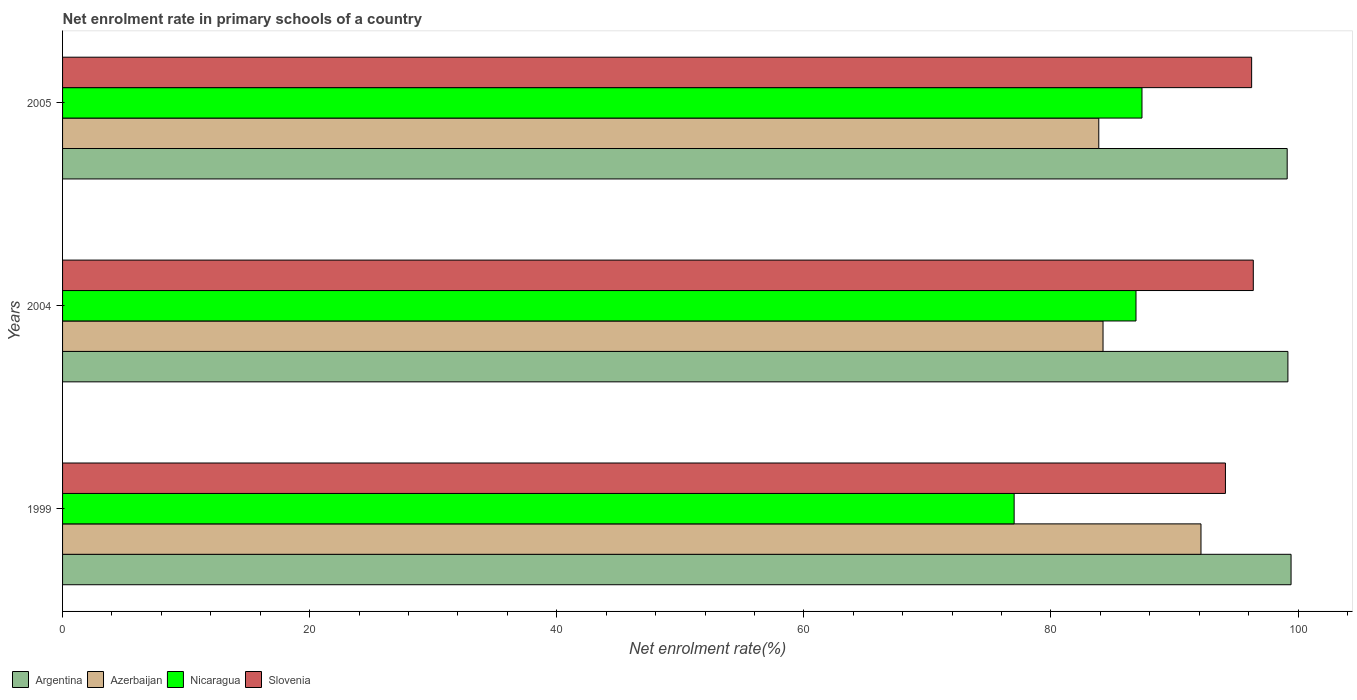Are the number of bars per tick equal to the number of legend labels?
Offer a very short reply. Yes. Are the number of bars on each tick of the Y-axis equal?
Your answer should be compact. Yes. In how many cases, is the number of bars for a given year not equal to the number of legend labels?
Give a very brief answer. 0. What is the net enrolment rate in primary schools in Slovenia in 2004?
Your answer should be very brief. 96.38. Across all years, what is the maximum net enrolment rate in primary schools in Slovenia?
Your response must be concise. 96.38. Across all years, what is the minimum net enrolment rate in primary schools in Nicaragua?
Provide a succinct answer. 77.02. In which year was the net enrolment rate in primary schools in Nicaragua maximum?
Provide a succinct answer. 2005. What is the total net enrolment rate in primary schools in Argentina in the graph?
Give a very brief answer. 297.73. What is the difference between the net enrolment rate in primary schools in Argentina in 1999 and that in 2005?
Ensure brevity in your answer.  0.31. What is the difference between the net enrolment rate in primary schools in Azerbaijan in 2005 and the net enrolment rate in primary schools in Nicaragua in 1999?
Your response must be concise. 6.85. What is the average net enrolment rate in primary schools in Argentina per year?
Give a very brief answer. 99.24. In the year 2005, what is the difference between the net enrolment rate in primary schools in Azerbaijan and net enrolment rate in primary schools in Nicaragua?
Your response must be concise. -3.5. In how many years, is the net enrolment rate in primary schools in Azerbaijan greater than 12 %?
Offer a very short reply. 3. What is the ratio of the net enrolment rate in primary schools in Azerbaijan in 2004 to that in 2005?
Give a very brief answer. 1. Is the net enrolment rate in primary schools in Argentina in 1999 less than that in 2004?
Offer a very short reply. No. Is the difference between the net enrolment rate in primary schools in Azerbaijan in 1999 and 2004 greater than the difference between the net enrolment rate in primary schools in Nicaragua in 1999 and 2004?
Your response must be concise. Yes. What is the difference between the highest and the second highest net enrolment rate in primary schools in Argentina?
Offer a terse response. 0.26. What is the difference between the highest and the lowest net enrolment rate in primary schools in Argentina?
Give a very brief answer. 0.31. In how many years, is the net enrolment rate in primary schools in Nicaragua greater than the average net enrolment rate in primary schools in Nicaragua taken over all years?
Give a very brief answer. 2. What does the 1st bar from the top in 2005 represents?
Your answer should be compact. Slovenia. What does the 4th bar from the bottom in 2004 represents?
Offer a terse response. Slovenia. Are all the bars in the graph horizontal?
Offer a terse response. Yes. How many years are there in the graph?
Give a very brief answer. 3. Are the values on the major ticks of X-axis written in scientific E-notation?
Keep it short and to the point. No. Does the graph contain any zero values?
Offer a very short reply. No. How are the legend labels stacked?
Give a very brief answer. Horizontal. What is the title of the graph?
Your answer should be compact. Net enrolment rate in primary schools of a country. Does "Cuba" appear as one of the legend labels in the graph?
Offer a very short reply. No. What is the label or title of the X-axis?
Give a very brief answer. Net enrolment rate(%). What is the label or title of the Y-axis?
Provide a succinct answer. Years. What is the Net enrolment rate(%) in Argentina in 1999?
Keep it short and to the point. 99.43. What is the Net enrolment rate(%) of Azerbaijan in 1999?
Ensure brevity in your answer.  92.14. What is the Net enrolment rate(%) of Nicaragua in 1999?
Ensure brevity in your answer.  77.02. What is the Net enrolment rate(%) of Slovenia in 1999?
Make the answer very short. 94.12. What is the Net enrolment rate(%) of Argentina in 2004?
Offer a terse response. 99.18. What is the Net enrolment rate(%) of Azerbaijan in 2004?
Keep it short and to the point. 84.21. What is the Net enrolment rate(%) in Nicaragua in 2004?
Make the answer very short. 86.88. What is the Net enrolment rate(%) of Slovenia in 2004?
Give a very brief answer. 96.38. What is the Net enrolment rate(%) of Argentina in 2005?
Offer a very short reply. 99.12. What is the Net enrolment rate(%) of Azerbaijan in 2005?
Your response must be concise. 83.87. What is the Net enrolment rate(%) of Nicaragua in 2005?
Provide a succinct answer. 87.37. What is the Net enrolment rate(%) in Slovenia in 2005?
Give a very brief answer. 96.24. Across all years, what is the maximum Net enrolment rate(%) in Argentina?
Ensure brevity in your answer.  99.43. Across all years, what is the maximum Net enrolment rate(%) of Azerbaijan?
Your answer should be compact. 92.14. Across all years, what is the maximum Net enrolment rate(%) in Nicaragua?
Your answer should be compact. 87.37. Across all years, what is the maximum Net enrolment rate(%) in Slovenia?
Your response must be concise. 96.38. Across all years, what is the minimum Net enrolment rate(%) in Argentina?
Ensure brevity in your answer.  99.12. Across all years, what is the minimum Net enrolment rate(%) in Azerbaijan?
Offer a terse response. 83.87. Across all years, what is the minimum Net enrolment rate(%) in Nicaragua?
Offer a very short reply. 77.02. Across all years, what is the minimum Net enrolment rate(%) in Slovenia?
Your response must be concise. 94.12. What is the total Net enrolment rate(%) of Argentina in the graph?
Ensure brevity in your answer.  297.73. What is the total Net enrolment rate(%) in Azerbaijan in the graph?
Give a very brief answer. 260.22. What is the total Net enrolment rate(%) in Nicaragua in the graph?
Your answer should be very brief. 251.26. What is the total Net enrolment rate(%) of Slovenia in the graph?
Provide a succinct answer. 286.74. What is the difference between the Net enrolment rate(%) in Argentina in 1999 and that in 2004?
Your answer should be very brief. 0.26. What is the difference between the Net enrolment rate(%) in Azerbaijan in 1999 and that in 2004?
Provide a short and direct response. 7.93. What is the difference between the Net enrolment rate(%) in Nicaragua in 1999 and that in 2004?
Ensure brevity in your answer.  -9.86. What is the difference between the Net enrolment rate(%) of Slovenia in 1999 and that in 2004?
Offer a terse response. -2.26. What is the difference between the Net enrolment rate(%) in Argentina in 1999 and that in 2005?
Ensure brevity in your answer.  0.31. What is the difference between the Net enrolment rate(%) in Azerbaijan in 1999 and that in 2005?
Your answer should be very brief. 8.27. What is the difference between the Net enrolment rate(%) in Nicaragua in 1999 and that in 2005?
Offer a terse response. -10.35. What is the difference between the Net enrolment rate(%) in Slovenia in 1999 and that in 2005?
Make the answer very short. -2.12. What is the difference between the Net enrolment rate(%) in Argentina in 2004 and that in 2005?
Your response must be concise. 0.06. What is the difference between the Net enrolment rate(%) of Azerbaijan in 2004 and that in 2005?
Make the answer very short. 0.34. What is the difference between the Net enrolment rate(%) in Nicaragua in 2004 and that in 2005?
Your answer should be very brief. -0.48. What is the difference between the Net enrolment rate(%) in Slovenia in 2004 and that in 2005?
Give a very brief answer. 0.13. What is the difference between the Net enrolment rate(%) of Argentina in 1999 and the Net enrolment rate(%) of Azerbaijan in 2004?
Your answer should be very brief. 15.22. What is the difference between the Net enrolment rate(%) of Argentina in 1999 and the Net enrolment rate(%) of Nicaragua in 2004?
Offer a very short reply. 12.55. What is the difference between the Net enrolment rate(%) in Argentina in 1999 and the Net enrolment rate(%) in Slovenia in 2004?
Offer a terse response. 3.06. What is the difference between the Net enrolment rate(%) in Azerbaijan in 1999 and the Net enrolment rate(%) in Nicaragua in 2004?
Your answer should be compact. 5.26. What is the difference between the Net enrolment rate(%) of Azerbaijan in 1999 and the Net enrolment rate(%) of Slovenia in 2004?
Give a very brief answer. -4.23. What is the difference between the Net enrolment rate(%) of Nicaragua in 1999 and the Net enrolment rate(%) of Slovenia in 2004?
Ensure brevity in your answer.  -19.36. What is the difference between the Net enrolment rate(%) in Argentina in 1999 and the Net enrolment rate(%) in Azerbaijan in 2005?
Make the answer very short. 15.56. What is the difference between the Net enrolment rate(%) in Argentina in 1999 and the Net enrolment rate(%) in Nicaragua in 2005?
Give a very brief answer. 12.07. What is the difference between the Net enrolment rate(%) in Argentina in 1999 and the Net enrolment rate(%) in Slovenia in 2005?
Your response must be concise. 3.19. What is the difference between the Net enrolment rate(%) in Azerbaijan in 1999 and the Net enrolment rate(%) in Nicaragua in 2005?
Give a very brief answer. 4.78. What is the difference between the Net enrolment rate(%) of Azerbaijan in 1999 and the Net enrolment rate(%) of Slovenia in 2005?
Your answer should be compact. -4.1. What is the difference between the Net enrolment rate(%) in Nicaragua in 1999 and the Net enrolment rate(%) in Slovenia in 2005?
Offer a terse response. -19.22. What is the difference between the Net enrolment rate(%) in Argentina in 2004 and the Net enrolment rate(%) in Azerbaijan in 2005?
Your response must be concise. 15.31. What is the difference between the Net enrolment rate(%) of Argentina in 2004 and the Net enrolment rate(%) of Nicaragua in 2005?
Your answer should be very brief. 11.81. What is the difference between the Net enrolment rate(%) of Argentina in 2004 and the Net enrolment rate(%) of Slovenia in 2005?
Ensure brevity in your answer.  2.94. What is the difference between the Net enrolment rate(%) in Azerbaijan in 2004 and the Net enrolment rate(%) in Nicaragua in 2005?
Provide a short and direct response. -3.15. What is the difference between the Net enrolment rate(%) of Azerbaijan in 2004 and the Net enrolment rate(%) of Slovenia in 2005?
Provide a short and direct response. -12.03. What is the difference between the Net enrolment rate(%) in Nicaragua in 2004 and the Net enrolment rate(%) in Slovenia in 2005?
Provide a short and direct response. -9.36. What is the average Net enrolment rate(%) in Argentina per year?
Your answer should be compact. 99.24. What is the average Net enrolment rate(%) of Azerbaijan per year?
Keep it short and to the point. 86.74. What is the average Net enrolment rate(%) of Nicaragua per year?
Offer a terse response. 83.75. What is the average Net enrolment rate(%) of Slovenia per year?
Make the answer very short. 95.58. In the year 1999, what is the difference between the Net enrolment rate(%) in Argentina and Net enrolment rate(%) in Azerbaijan?
Ensure brevity in your answer.  7.29. In the year 1999, what is the difference between the Net enrolment rate(%) of Argentina and Net enrolment rate(%) of Nicaragua?
Ensure brevity in your answer.  22.41. In the year 1999, what is the difference between the Net enrolment rate(%) in Argentina and Net enrolment rate(%) in Slovenia?
Provide a succinct answer. 5.31. In the year 1999, what is the difference between the Net enrolment rate(%) in Azerbaijan and Net enrolment rate(%) in Nicaragua?
Provide a short and direct response. 15.12. In the year 1999, what is the difference between the Net enrolment rate(%) in Azerbaijan and Net enrolment rate(%) in Slovenia?
Give a very brief answer. -1.98. In the year 1999, what is the difference between the Net enrolment rate(%) in Nicaragua and Net enrolment rate(%) in Slovenia?
Offer a very short reply. -17.1. In the year 2004, what is the difference between the Net enrolment rate(%) of Argentina and Net enrolment rate(%) of Azerbaijan?
Your answer should be compact. 14.96. In the year 2004, what is the difference between the Net enrolment rate(%) of Argentina and Net enrolment rate(%) of Nicaragua?
Offer a terse response. 12.3. In the year 2004, what is the difference between the Net enrolment rate(%) of Argentina and Net enrolment rate(%) of Slovenia?
Offer a very short reply. 2.8. In the year 2004, what is the difference between the Net enrolment rate(%) of Azerbaijan and Net enrolment rate(%) of Nicaragua?
Provide a short and direct response. -2.67. In the year 2004, what is the difference between the Net enrolment rate(%) of Azerbaijan and Net enrolment rate(%) of Slovenia?
Offer a very short reply. -12.16. In the year 2004, what is the difference between the Net enrolment rate(%) in Nicaragua and Net enrolment rate(%) in Slovenia?
Ensure brevity in your answer.  -9.49. In the year 2005, what is the difference between the Net enrolment rate(%) in Argentina and Net enrolment rate(%) in Azerbaijan?
Offer a terse response. 15.25. In the year 2005, what is the difference between the Net enrolment rate(%) of Argentina and Net enrolment rate(%) of Nicaragua?
Offer a very short reply. 11.75. In the year 2005, what is the difference between the Net enrolment rate(%) of Argentina and Net enrolment rate(%) of Slovenia?
Offer a very short reply. 2.88. In the year 2005, what is the difference between the Net enrolment rate(%) in Azerbaijan and Net enrolment rate(%) in Nicaragua?
Provide a succinct answer. -3.5. In the year 2005, what is the difference between the Net enrolment rate(%) in Azerbaijan and Net enrolment rate(%) in Slovenia?
Give a very brief answer. -12.37. In the year 2005, what is the difference between the Net enrolment rate(%) of Nicaragua and Net enrolment rate(%) of Slovenia?
Give a very brief answer. -8.88. What is the ratio of the Net enrolment rate(%) in Azerbaijan in 1999 to that in 2004?
Make the answer very short. 1.09. What is the ratio of the Net enrolment rate(%) in Nicaragua in 1999 to that in 2004?
Your response must be concise. 0.89. What is the ratio of the Net enrolment rate(%) of Slovenia in 1999 to that in 2004?
Ensure brevity in your answer.  0.98. What is the ratio of the Net enrolment rate(%) in Argentina in 1999 to that in 2005?
Your answer should be compact. 1. What is the ratio of the Net enrolment rate(%) in Azerbaijan in 1999 to that in 2005?
Offer a very short reply. 1.1. What is the ratio of the Net enrolment rate(%) in Nicaragua in 1999 to that in 2005?
Provide a succinct answer. 0.88. What is the ratio of the Net enrolment rate(%) in Argentina in 2004 to that in 2005?
Offer a terse response. 1. What is the ratio of the Net enrolment rate(%) in Slovenia in 2004 to that in 2005?
Offer a very short reply. 1. What is the difference between the highest and the second highest Net enrolment rate(%) in Argentina?
Provide a short and direct response. 0.26. What is the difference between the highest and the second highest Net enrolment rate(%) of Azerbaijan?
Ensure brevity in your answer.  7.93. What is the difference between the highest and the second highest Net enrolment rate(%) in Nicaragua?
Ensure brevity in your answer.  0.48. What is the difference between the highest and the second highest Net enrolment rate(%) in Slovenia?
Offer a very short reply. 0.13. What is the difference between the highest and the lowest Net enrolment rate(%) in Argentina?
Offer a very short reply. 0.31. What is the difference between the highest and the lowest Net enrolment rate(%) in Azerbaijan?
Ensure brevity in your answer.  8.27. What is the difference between the highest and the lowest Net enrolment rate(%) in Nicaragua?
Your answer should be very brief. 10.35. What is the difference between the highest and the lowest Net enrolment rate(%) in Slovenia?
Your answer should be compact. 2.26. 